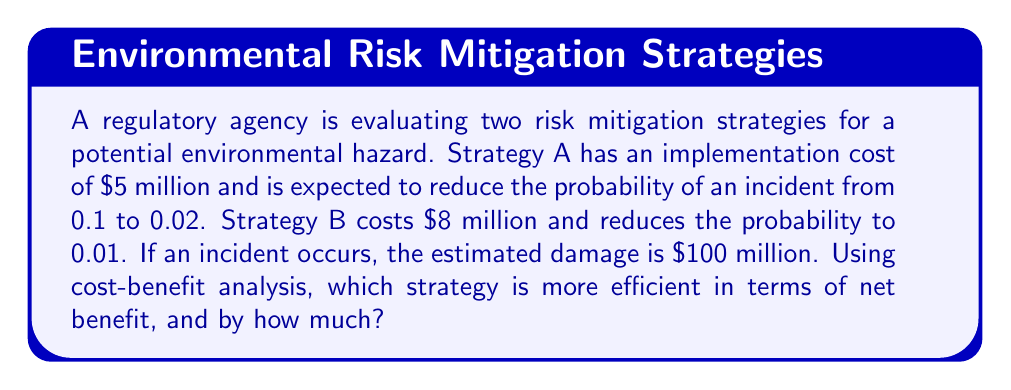Can you solve this math problem? To evaluate the efficiency of these risk mitigation strategies, we'll use cost-benefit analysis:

1. Calculate the expected cost of an incident without mitigation:
   $E(\text{cost})_{\text{no mitigation}} = 0.1 \times \$100\text{ million} = \$10\text{ million}$

2. Calculate the expected cost with each strategy:
   Strategy A: $E(\text{cost})_A = 0.02 \times \$100\text{ million} = \$2\text{ million}$
   Strategy B: $E(\text{cost})_B = 0.01 \times \$100\text{ million} = \$1\text{ million}$

3. Calculate the benefit (reduction in expected cost) for each strategy:
   Benefit A = $\$10\text{ million} - \$2\text{ million} = \$8\text{ million}$
   Benefit B = $\$10\text{ million} - \$1\text{ million} = \$9\text{ million}$

4. Calculate the net benefit (benefit minus cost) for each strategy:
   Net Benefit A = $\$8\text{ million} - \$5\text{ million} = \$3\text{ million}$
   Net Benefit B = $\$9\text{ million} - \$8\text{ million} = \$1\text{ million}$

5. Compare the net benefits:
   Strategy A has a higher net benefit by $\$3\text{ million} - \$1\text{ million} = \$2\text{ million}$

Therefore, Strategy A is more efficient in terms of net benefit, by $2 million.
Answer: Strategy A; $2 million 